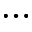Convert formula to latex. <formula><loc_0><loc_0><loc_500><loc_500>\dots</formula> 